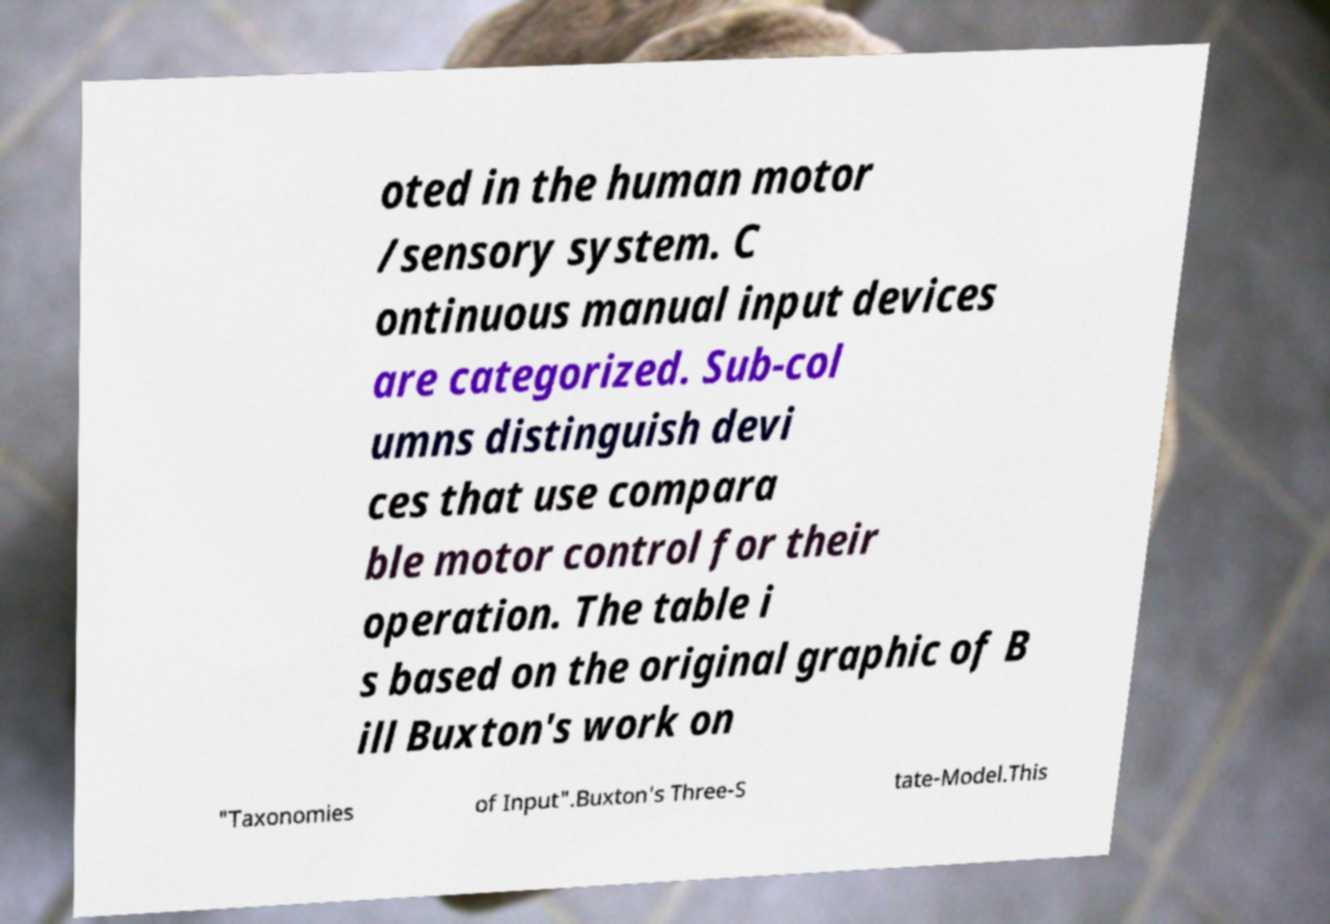For documentation purposes, I need the text within this image transcribed. Could you provide that? oted in the human motor /sensory system. C ontinuous manual input devices are categorized. Sub-col umns distinguish devi ces that use compara ble motor control for their operation. The table i s based on the original graphic of B ill Buxton's work on "Taxonomies of Input".Buxton's Three-S tate-Model.This 